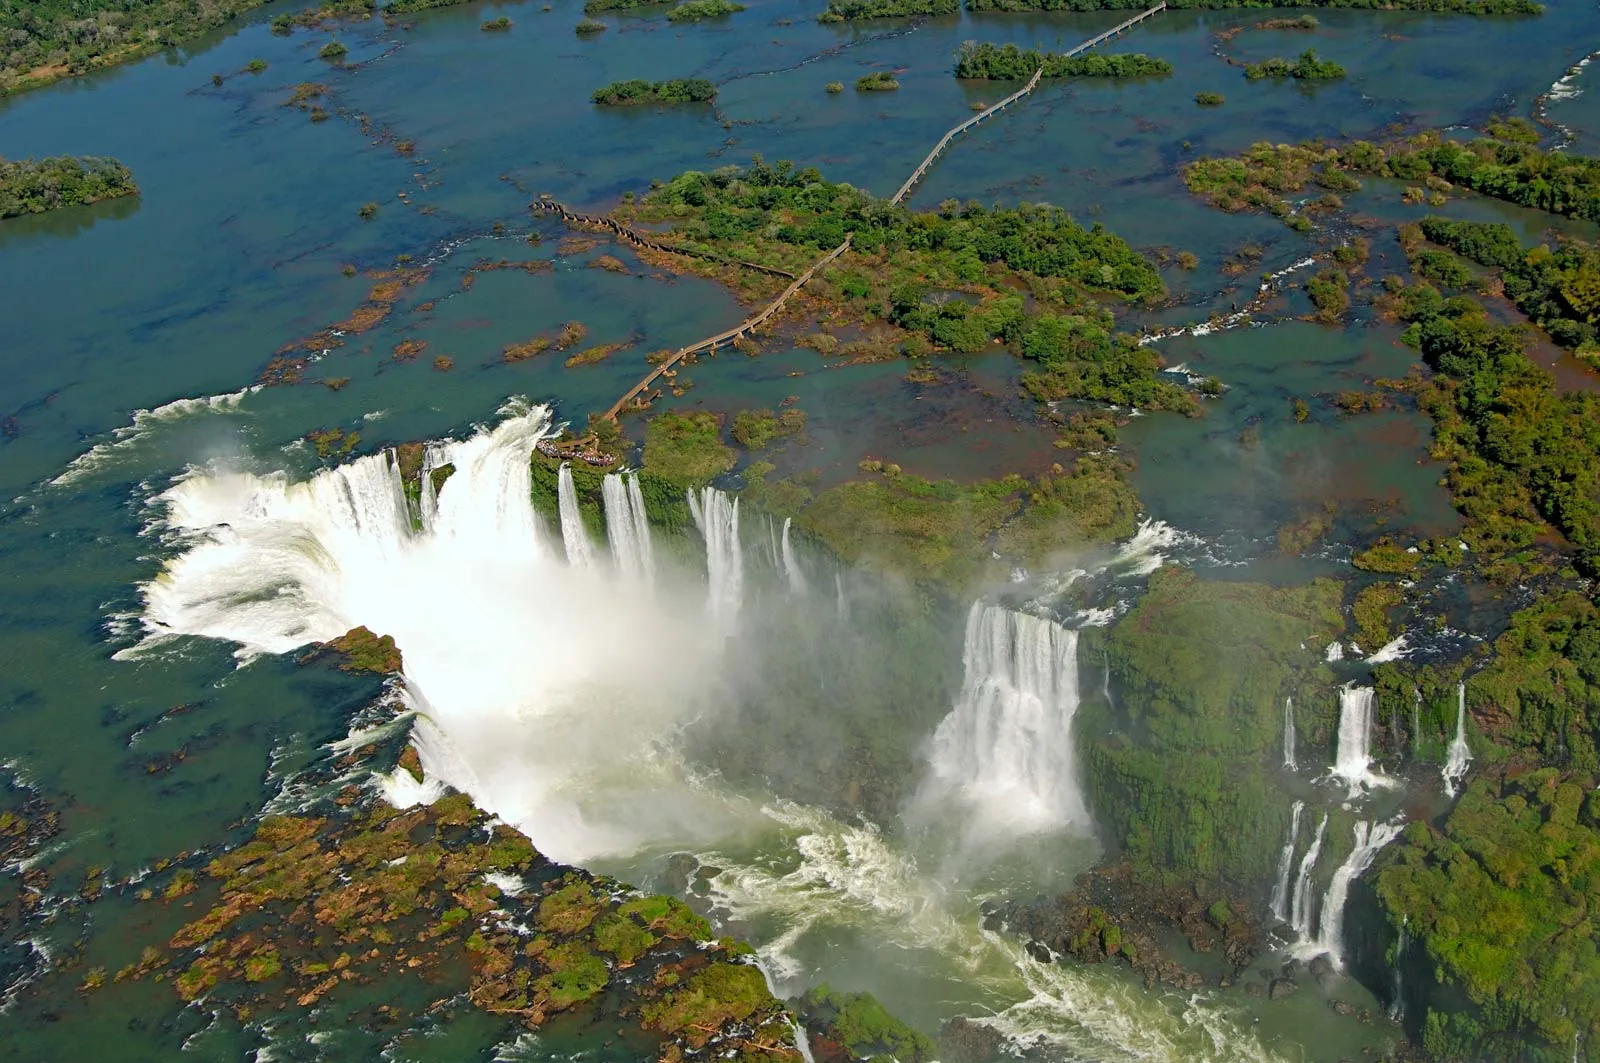What are the key elements in this picture? This image showcases the awe-inspiring Iguazu Falls, located on the border between Argentina and Brazil. Dominating the scene is the series of majestic waterfalls cascading down with tremendous force, their white foam contrasting with the surrounding blue-green waters. The dense, lush greenery envelopes the falls, providing a vibrant backdrop to the natural spectacle. The mist from the falls rises up, adding a sense of dynamism and ethereal charm to the image. The overall view, presumably taken from an aerial perspective, captures both the raw power and serene beauty of this iconic natural landmark. 